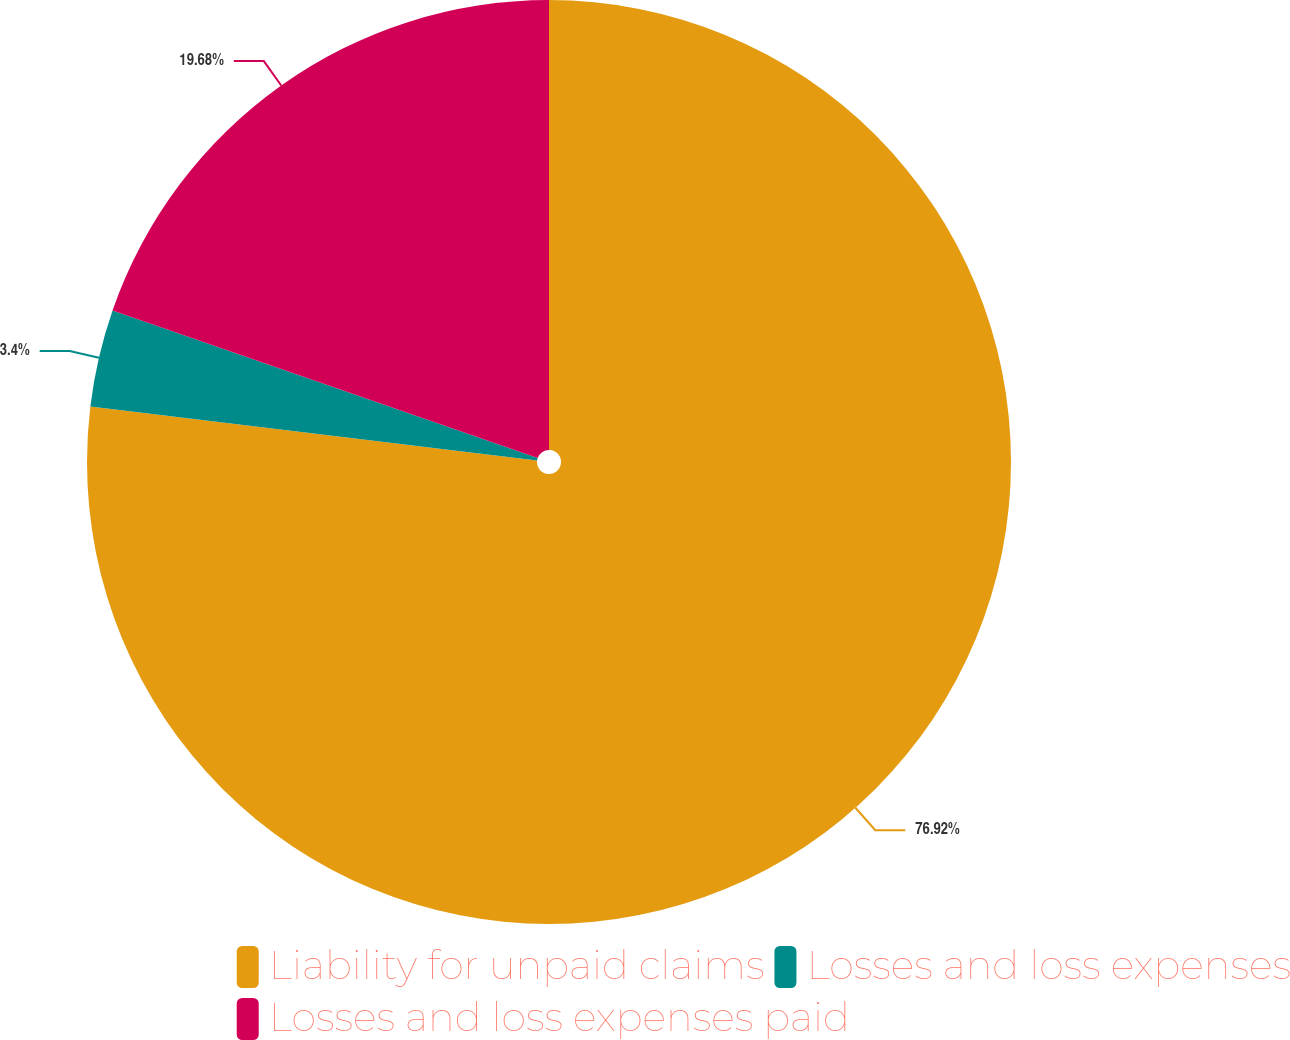Convert chart. <chart><loc_0><loc_0><loc_500><loc_500><pie_chart><fcel>Liability for unpaid claims<fcel>Losses and loss expenses<fcel>Losses and loss expenses paid<nl><fcel>76.92%<fcel>3.4%<fcel>19.68%<nl></chart> 